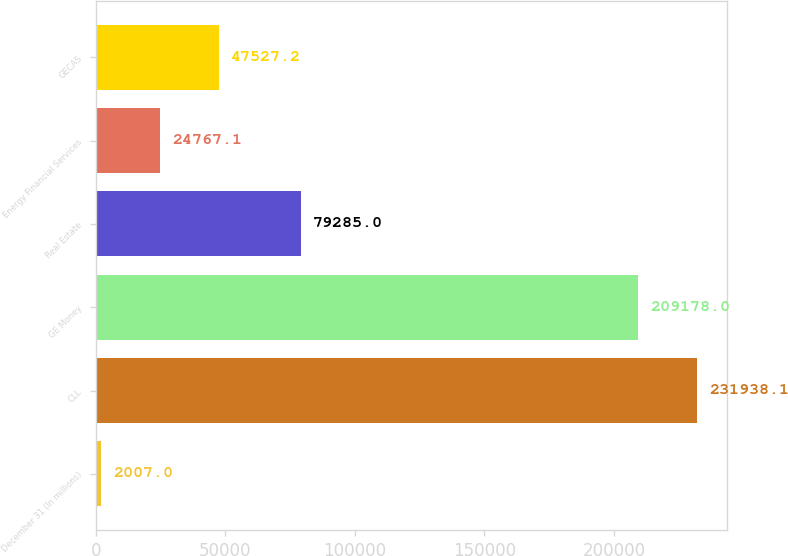Convert chart. <chart><loc_0><loc_0><loc_500><loc_500><bar_chart><fcel>December 31 (In millions)<fcel>CLL<fcel>GE Money<fcel>Real Estate<fcel>Energy Financial Services<fcel>GECAS<nl><fcel>2007<fcel>231938<fcel>209178<fcel>79285<fcel>24767.1<fcel>47527.2<nl></chart> 